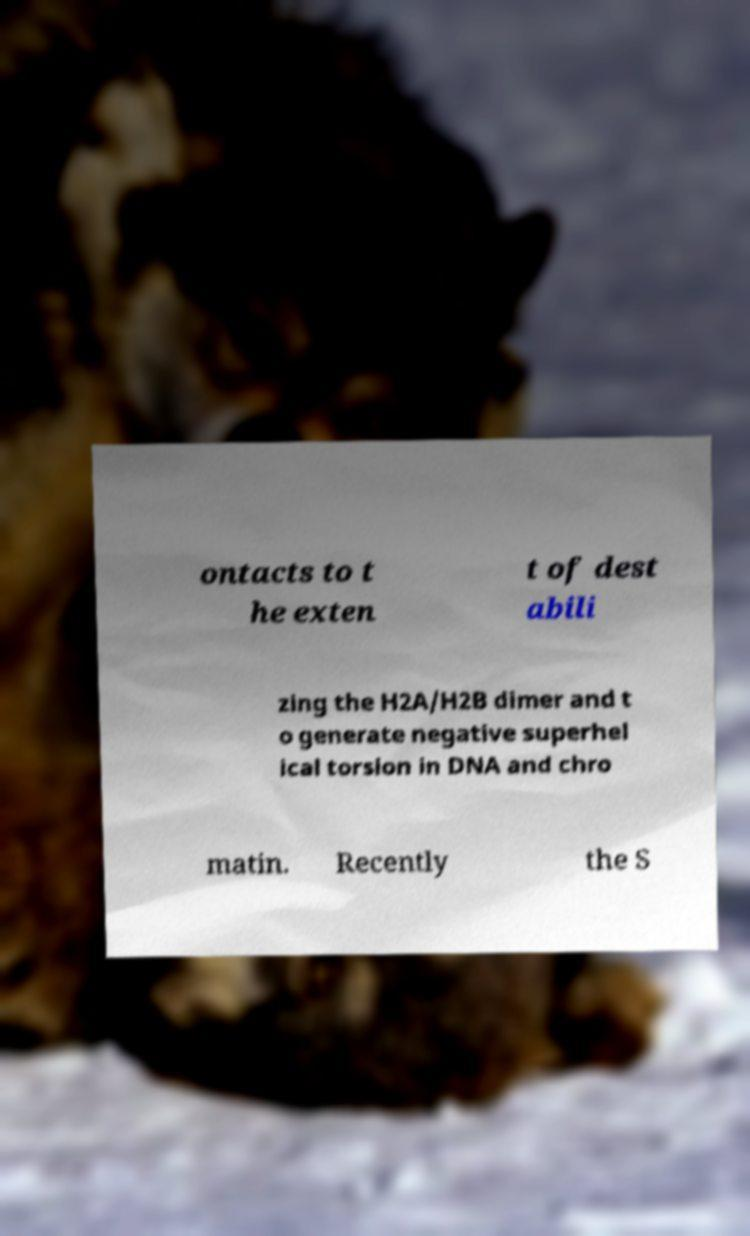Please identify and transcribe the text found in this image. ontacts to t he exten t of dest abili zing the H2A/H2B dimer and t o generate negative superhel ical torsion in DNA and chro matin. Recently the S 